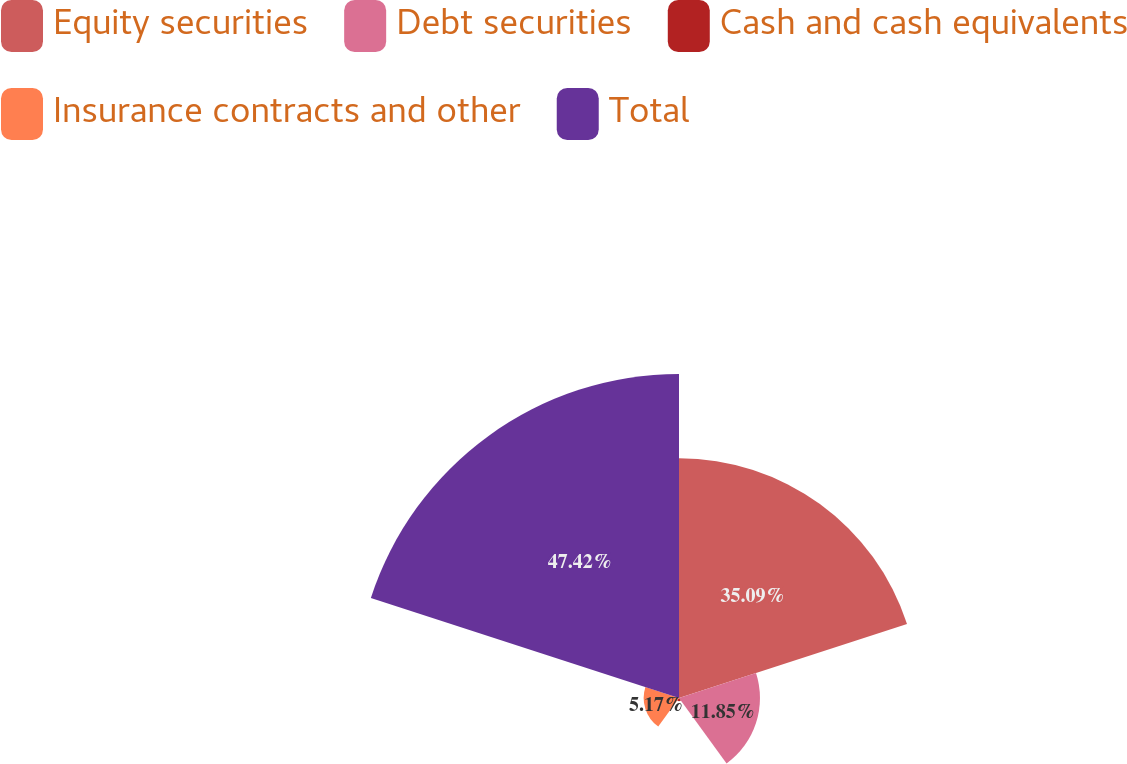<chart> <loc_0><loc_0><loc_500><loc_500><pie_chart><fcel>Equity securities<fcel>Debt securities<fcel>Cash and cash equivalents<fcel>Insurance contracts and other<fcel>Total<nl><fcel>35.09%<fcel>11.85%<fcel>0.47%<fcel>5.17%<fcel>47.42%<nl></chart> 